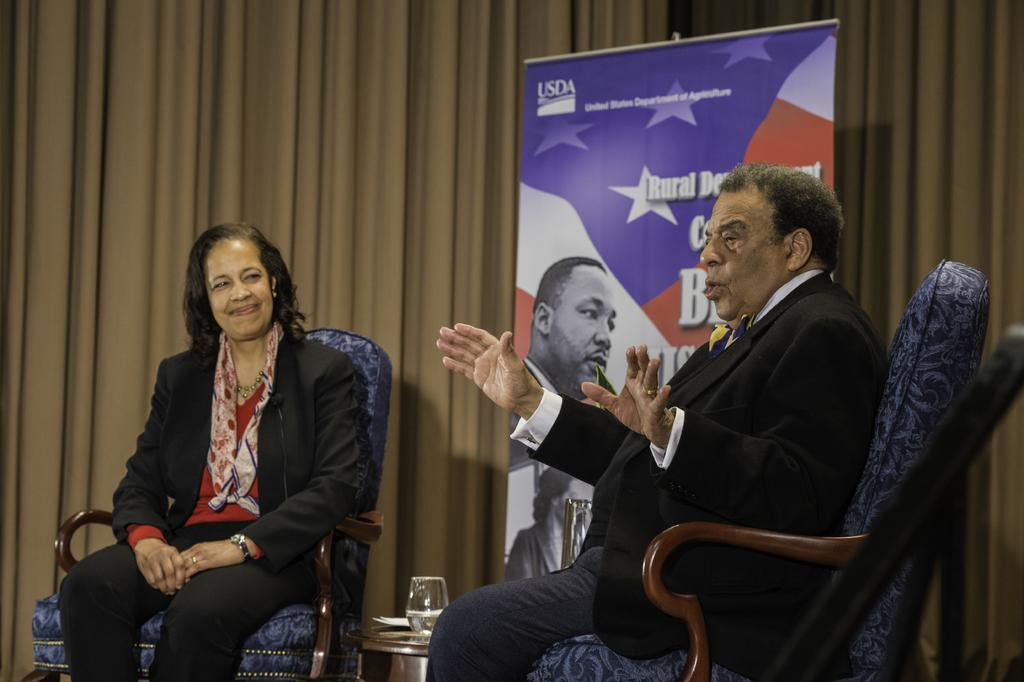What are the people in the image doing? The people in the image are sitting on chairs. How many people can be seen in the image? There are people visible in the image. What is written on the banner in the image? There is a banner with text in the image. What type of covering is present in the image? There is a curtain in the image. What is on the table in the image? There are objects on a table in the image. What type of skirt is the chair wearing in the image? Chairs do not wear skirts; they are inanimate objects. 